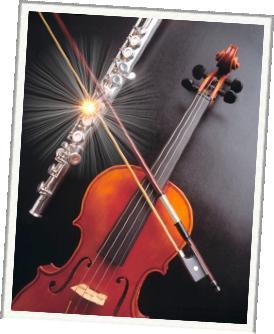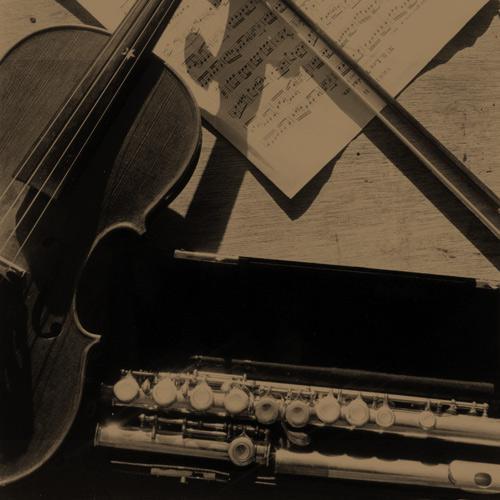The first image is the image on the left, the second image is the image on the right. Considering the images on both sides, is "A violin bow is touching violin strings and a flute." valid? Answer yes or no. Yes. The first image is the image on the left, the second image is the image on the right. For the images displayed, is the sentence "An image features items displayed overlapping on a flat surface, including a violin, sheet music, and a straight wind instrument in pieces." factually correct? Answer yes or no. Yes. 